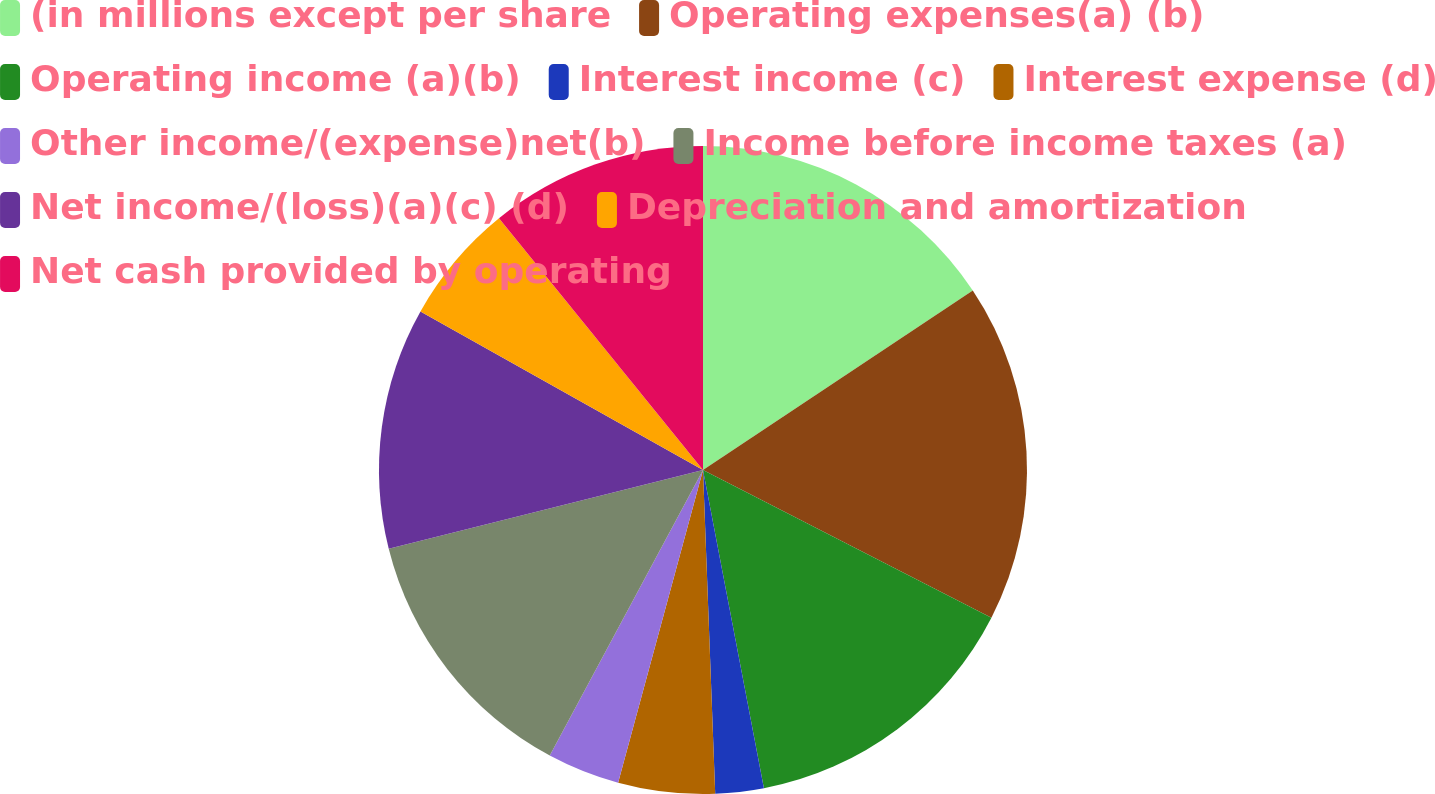Convert chart. <chart><loc_0><loc_0><loc_500><loc_500><pie_chart><fcel>(in millions except per share<fcel>Operating expenses(a) (b)<fcel>Operating income (a)(b)<fcel>Interest income (c)<fcel>Interest expense (d)<fcel>Other income/(expense)net(b)<fcel>Income before income taxes (a)<fcel>Net income/(loss)(a)(c) (d)<fcel>Depreciation and amortization<fcel>Net cash provided by operating<nl><fcel>15.66%<fcel>16.87%<fcel>14.46%<fcel>2.41%<fcel>4.82%<fcel>3.62%<fcel>13.25%<fcel>12.05%<fcel>6.02%<fcel>10.84%<nl></chart> 